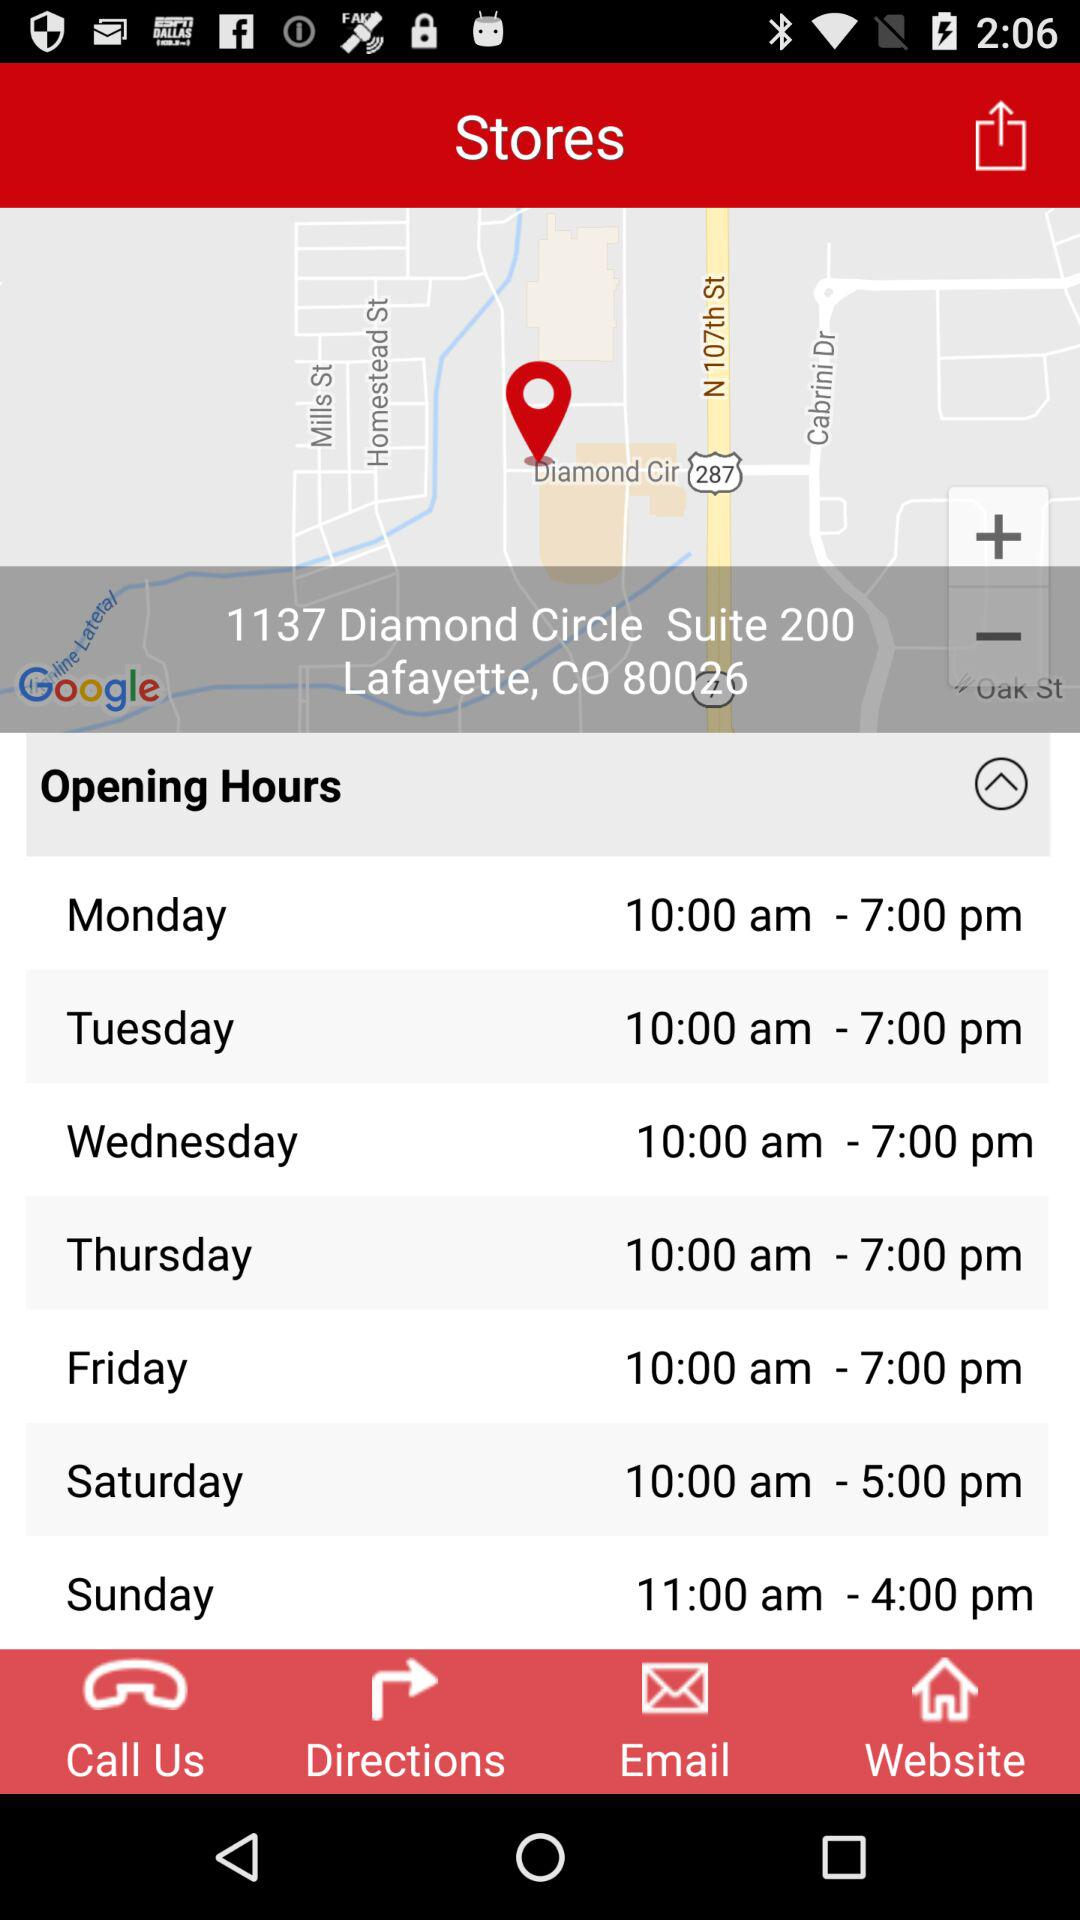How many more hours is the store open on Sunday than on Monday?
Answer the question using a single word or phrase. 3 